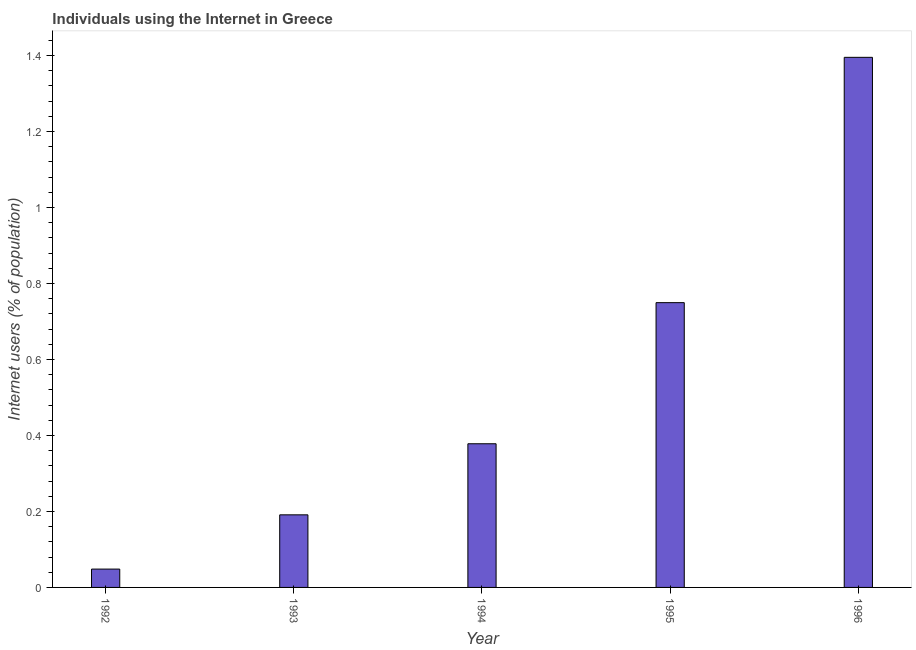What is the title of the graph?
Keep it short and to the point. Individuals using the Internet in Greece. What is the label or title of the Y-axis?
Provide a short and direct response. Internet users (% of population). What is the number of internet users in 1992?
Make the answer very short. 0.05. Across all years, what is the maximum number of internet users?
Your answer should be compact. 1.4. Across all years, what is the minimum number of internet users?
Your answer should be very brief. 0.05. In which year was the number of internet users minimum?
Your answer should be very brief. 1992. What is the sum of the number of internet users?
Make the answer very short. 2.76. What is the difference between the number of internet users in 1995 and 1996?
Provide a succinct answer. -0.65. What is the average number of internet users per year?
Offer a very short reply. 0.55. What is the median number of internet users?
Make the answer very short. 0.38. In how many years, is the number of internet users greater than 1.32 %?
Provide a succinct answer. 1. Do a majority of the years between 1995 and 1994 (inclusive) have number of internet users greater than 0.8 %?
Ensure brevity in your answer.  No. What is the ratio of the number of internet users in 1993 to that in 1996?
Your answer should be very brief. 0.14. Is the difference between the number of internet users in 1995 and 1996 greater than the difference between any two years?
Give a very brief answer. No. What is the difference between the highest and the second highest number of internet users?
Your answer should be very brief. 0.65. What is the difference between the highest and the lowest number of internet users?
Give a very brief answer. 1.35. How many bars are there?
Your answer should be very brief. 5. How many years are there in the graph?
Keep it short and to the point. 5. What is the Internet users (% of population) in 1992?
Your answer should be very brief. 0.05. What is the Internet users (% of population) of 1993?
Offer a very short reply. 0.19. What is the Internet users (% of population) of 1994?
Provide a short and direct response. 0.38. What is the Internet users (% of population) of 1995?
Provide a succinct answer. 0.75. What is the Internet users (% of population) in 1996?
Your answer should be compact. 1.4. What is the difference between the Internet users (% of population) in 1992 and 1993?
Provide a succinct answer. -0.14. What is the difference between the Internet users (% of population) in 1992 and 1994?
Keep it short and to the point. -0.33. What is the difference between the Internet users (% of population) in 1992 and 1995?
Ensure brevity in your answer.  -0.7. What is the difference between the Internet users (% of population) in 1992 and 1996?
Make the answer very short. -1.35. What is the difference between the Internet users (% of population) in 1993 and 1994?
Keep it short and to the point. -0.19. What is the difference between the Internet users (% of population) in 1993 and 1995?
Offer a terse response. -0.56. What is the difference between the Internet users (% of population) in 1993 and 1996?
Offer a very short reply. -1.2. What is the difference between the Internet users (% of population) in 1994 and 1995?
Offer a very short reply. -0.37. What is the difference between the Internet users (% of population) in 1994 and 1996?
Your answer should be very brief. -1.02. What is the difference between the Internet users (% of population) in 1995 and 1996?
Your answer should be compact. -0.65. What is the ratio of the Internet users (% of population) in 1992 to that in 1993?
Ensure brevity in your answer.  0.25. What is the ratio of the Internet users (% of population) in 1992 to that in 1994?
Your response must be concise. 0.13. What is the ratio of the Internet users (% of population) in 1992 to that in 1995?
Make the answer very short. 0.06. What is the ratio of the Internet users (% of population) in 1992 to that in 1996?
Offer a very short reply. 0.04. What is the ratio of the Internet users (% of population) in 1993 to that in 1994?
Offer a terse response. 0.51. What is the ratio of the Internet users (% of population) in 1993 to that in 1995?
Offer a terse response. 0.26. What is the ratio of the Internet users (% of population) in 1993 to that in 1996?
Provide a short and direct response. 0.14. What is the ratio of the Internet users (% of population) in 1994 to that in 1995?
Your response must be concise. 0.5. What is the ratio of the Internet users (% of population) in 1994 to that in 1996?
Keep it short and to the point. 0.27. What is the ratio of the Internet users (% of population) in 1995 to that in 1996?
Provide a succinct answer. 0.54. 